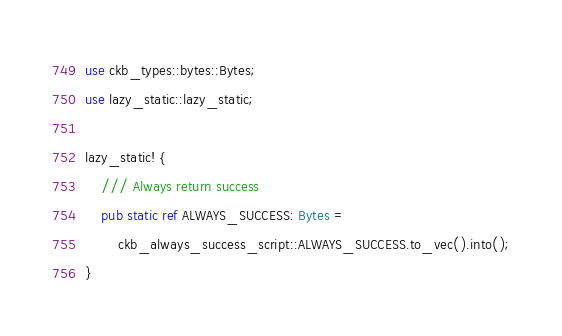Convert code to text. <code><loc_0><loc_0><loc_500><loc_500><_Rust_>
use ckb_types::bytes::Bytes;
use lazy_static::lazy_static;

lazy_static! {
    /// Always return success
    pub static ref ALWAYS_SUCCESS: Bytes =
        ckb_always_success_script::ALWAYS_SUCCESS.to_vec().into();
}
</code> 